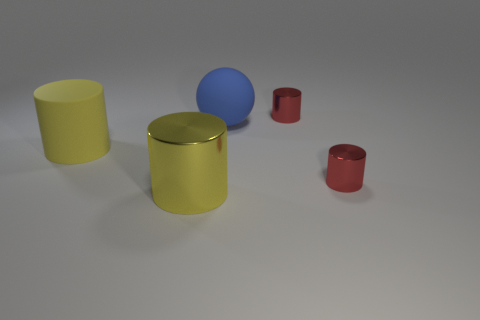What number of blue things are made of the same material as the large ball?
Your answer should be very brief. 0. Does the yellow rubber cylinder have the same size as the blue rubber sphere?
Offer a very short reply. Yes. Is there any other thing that has the same color as the big matte ball?
Provide a short and direct response. No. The object that is both on the left side of the large ball and behind the big yellow shiny thing has what shape?
Ensure brevity in your answer.  Cylinder. There is a shiny object behind the yellow matte thing; how big is it?
Make the answer very short. Small. There is a small object that is in front of the rubber cylinder to the left of the big blue sphere; what number of small red metallic objects are behind it?
Keep it short and to the point. 1. There is a blue rubber object; are there any small metal things in front of it?
Give a very brief answer. Yes. How many other objects are there of the same size as the rubber cylinder?
Provide a succinct answer. 2. The object that is both in front of the blue matte sphere and right of the big metallic object is made of what material?
Give a very brief answer. Metal. There is a tiny metallic object in front of the blue ball; is its shape the same as the yellow thing that is left of the big metallic object?
Your answer should be very brief. Yes. 